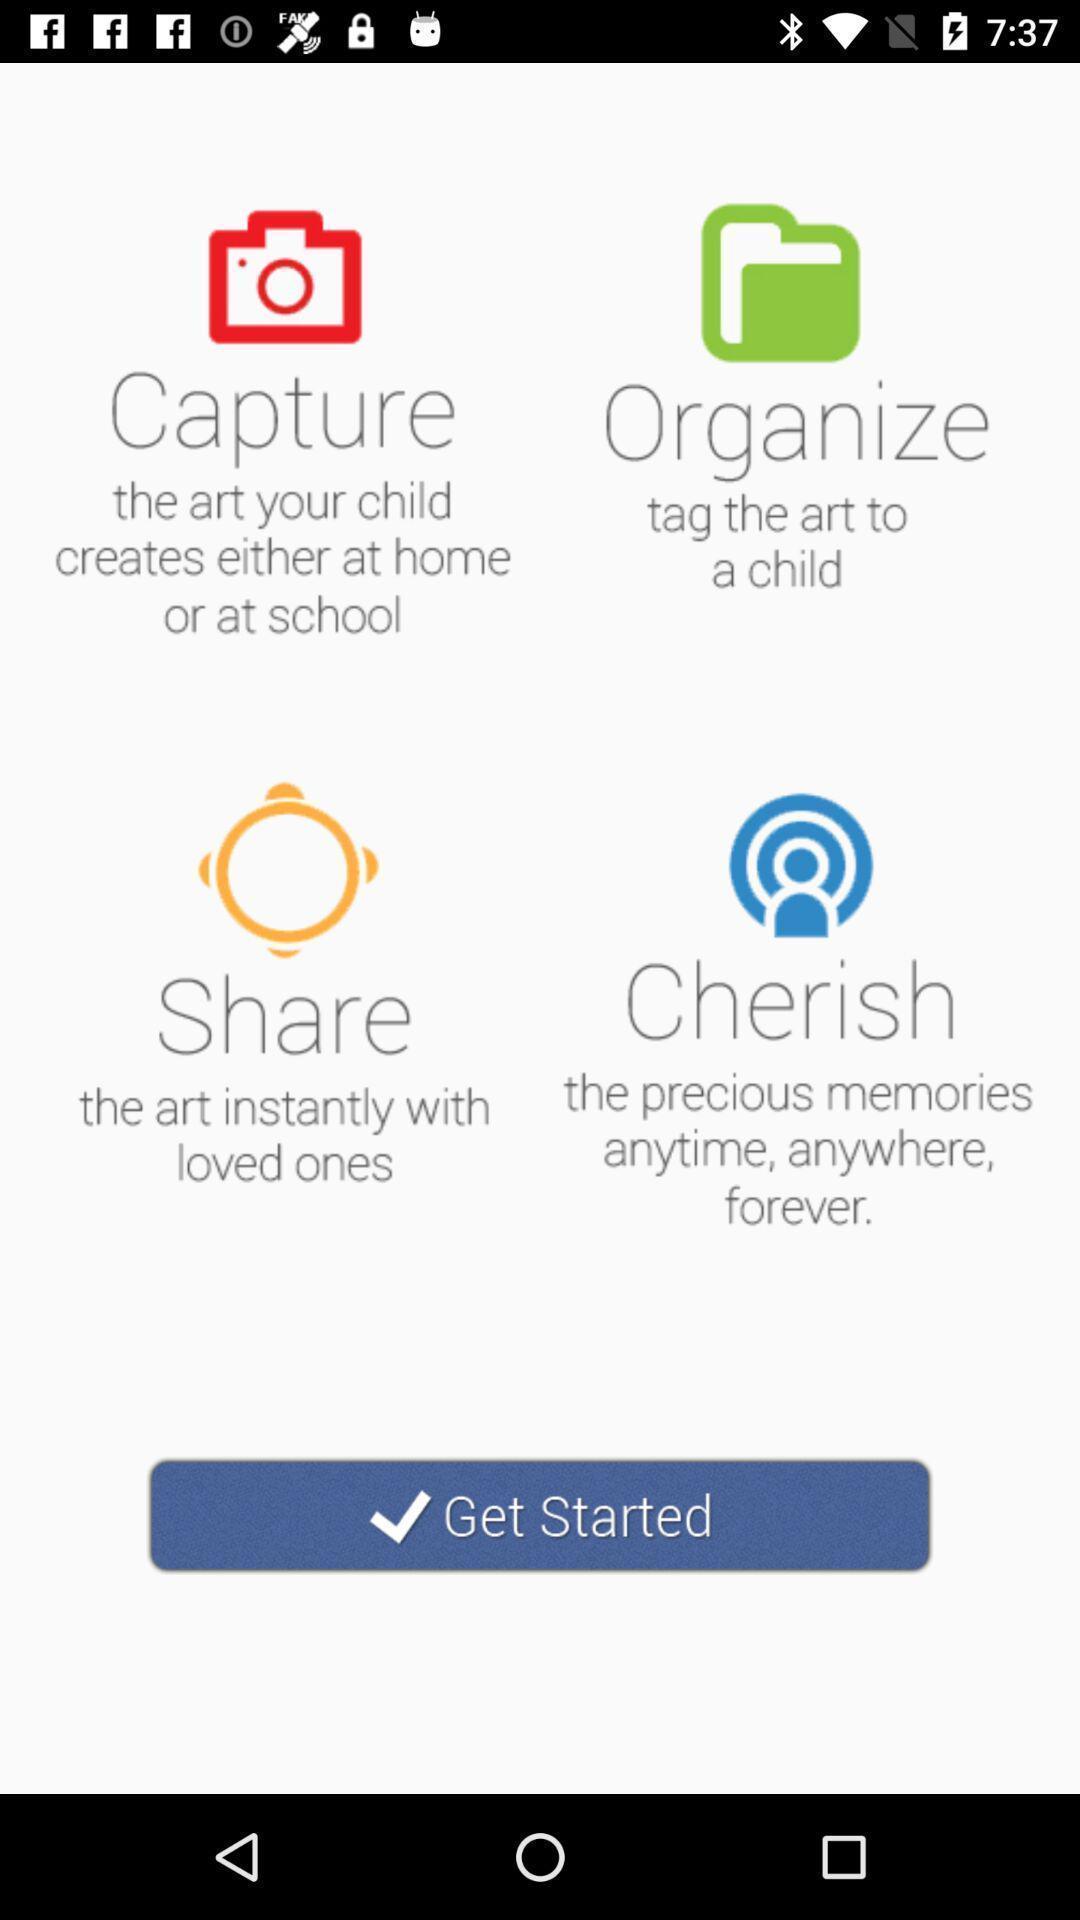Summarize the information in this screenshot. Window displaying a child learning app. 